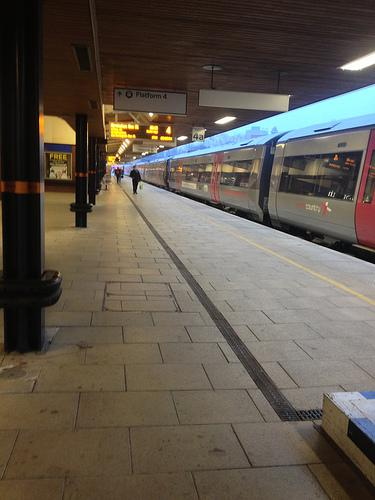Question: how is the weather?
Choices:
A. Sunny.
B. Foggy.
C. Overcast.
D. Rainy.
Answer with the letter. Answer: C Question: who is shown?
Choices:
A. A few people.
B. A man.
C. A child.
D. A crowd of protestors.
Answer with the letter. Answer: A Question: where is this scene?
Choices:
A. A train station.
B. A park.
C. A forest.
D. A zoo.
Answer with the letter. Answer: A Question: what are the people doing?
Choices:
A. Waiting for a train.
B. Jogging.
C. Shopping.
D. Playing a game.
Answer with the letter. Answer: A Question: what platform is this?
Choices:
A. Two.
B. Four.
C. Seven.
D. Six.
Answer with the letter. Answer: B 